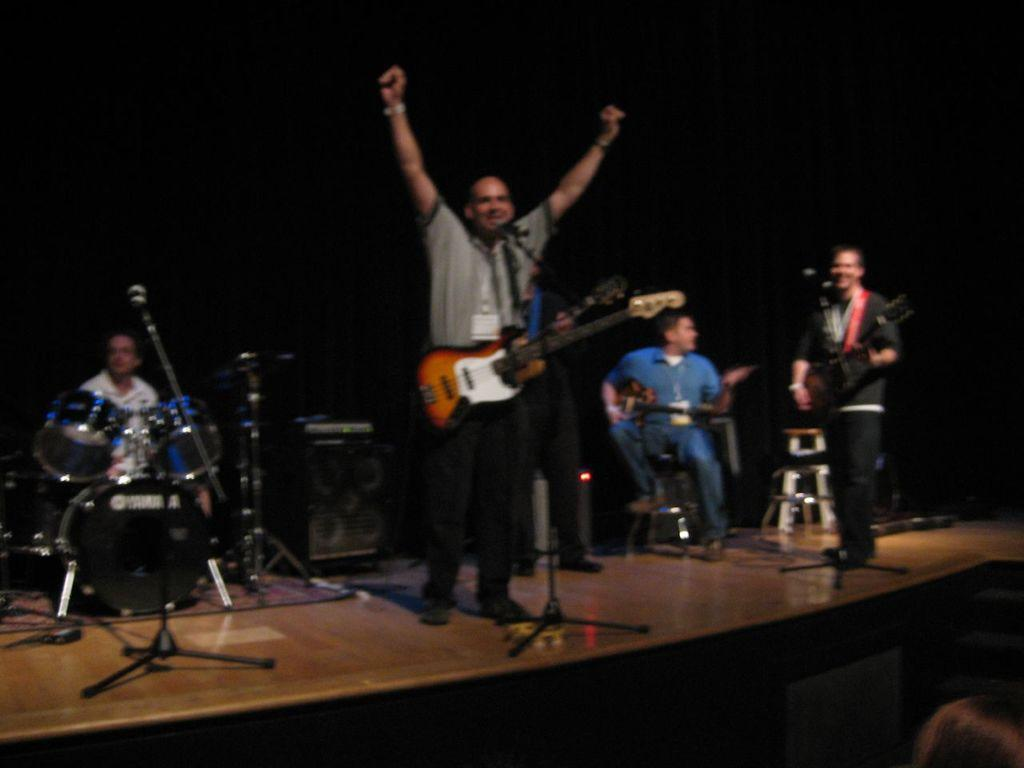What is the man in the image doing? The man is singing in the image. What is the man holding while singing? The man is holding a microphone and a guitar. Can you describe the other musicians in the image? There is a man playing the drums, and he is on the right side of the image. Are there any other people in the image besides the musicians? Yes, there is a man standing and smiling in the image. What type of liquid is being poured over the cabbage in the image? There is no liquid or cabbage present in the image; it features musicians playing instruments. What time of day is it in the image? The provided facts do not mention the time of day, so it cannot be determined from the image. 